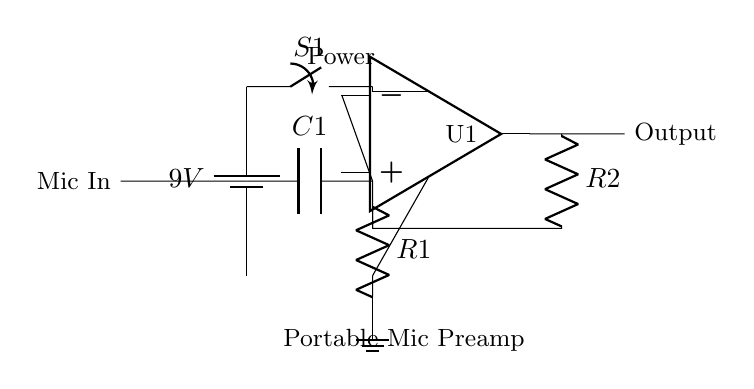What is the battery voltage in the circuit? The battery voltage is indicated next to the battery symbol and is specified as 9 volts.
Answer: 9V What components are used in this microphone preamp circuit? The circuit includes a battery, switch, microphone input, capacitor, operational amplifier, resistors, and ground.
Answer: Battery, switch, microphone input, capacitor, operational amplifier, resistors, ground What is the purpose of the capacitor labeled C1? The capacitor C1 serves to block any DC voltage while allowing the AC audio signal from the microphone to pass through to the operational amplifier.
Answer: Block DC voltage How many resistors are present in the circuit, and what are their labels? There are two resistors in the circuit, labeled R1 and R2. R1 is connected to the feedback path and R2 is part of the output network.
Answer: Two, R1 and R2 What is the function of the operational amplifier in this design? The operational amplifier amplifies the small voltage signal from the microphone to a level suitable for further processing or output.
Answer: Amplifies signal What kind of device is this circuit designed for? This circuit is designed for a portable microphone preamplifier. It is specified to be battery-powered and geared for on-location sound recording.
Answer: Portable microphone preamp 